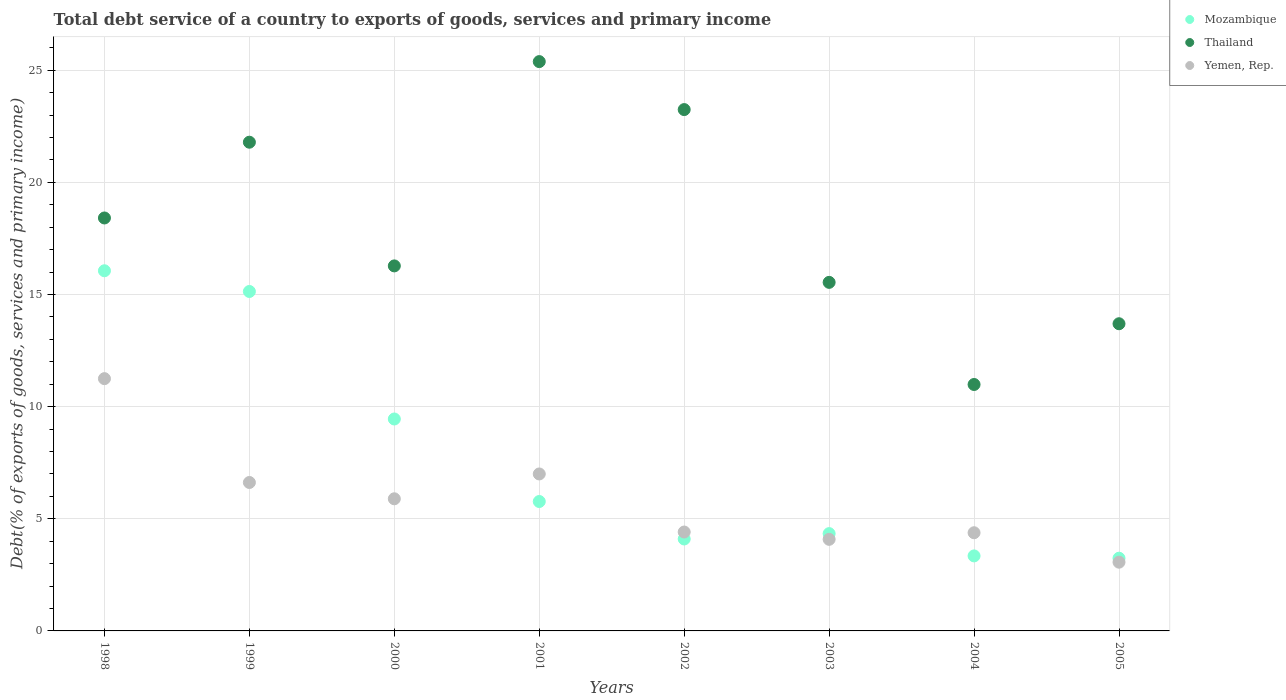How many different coloured dotlines are there?
Your answer should be compact. 3. Is the number of dotlines equal to the number of legend labels?
Ensure brevity in your answer.  Yes. What is the total debt service in Mozambique in 2001?
Offer a very short reply. 5.77. Across all years, what is the maximum total debt service in Mozambique?
Offer a very short reply. 16.06. Across all years, what is the minimum total debt service in Yemen, Rep.?
Give a very brief answer. 3.06. In which year was the total debt service in Thailand minimum?
Give a very brief answer. 2004. What is the total total debt service in Yemen, Rep. in the graph?
Your answer should be very brief. 46.69. What is the difference between the total debt service in Yemen, Rep. in 2001 and that in 2002?
Your response must be concise. 2.59. What is the difference between the total debt service in Thailand in 2004 and the total debt service in Yemen, Rep. in 1999?
Give a very brief answer. 4.37. What is the average total debt service in Yemen, Rep. per year?
Your answer should be very brief. 5.84. In the year 1998, what is the difference between the total debt service in Thailand and total debt service in Yemen, Rep.?
Offer a terse response. 7.16. In how many years, is the total debt service in Mozambique greater than 13 %?
Offer a terse response. 2. What is the ratio of the total debt service in Mozambique in 1999 to that in 2004?
Your answer should be very brief. 4.52. Is the total debt service in Yemen, Rep. in 2002 less than that in 2005?
Give a very brief answer. No. What is the difference between the highest and the second highest total debt service in Yemen, Rep.?
Ensure brevity in your answer.  4.25. What is the difference between the highest and the lowest total debt service in Yemen, Rep.?
Make the answer very short. 8.18. Is the sum of the total debt service in Thailand in 1998 and 1999 greater than the maximum total debt service in Mozambique across all years?
Give a very brief answer. Yes. Does the total debt service in Yemen, Rep. monotonically increase over the years?
Your answer should be very brief. No. Is the total debt service in Thailand strictly greater than the total debt service in Yemen, Rep. over the years?
Give a very brief answer. Yes. Is the total debt service in Thailand strictly less than the total debt service in Yemen, Rep. over the years?
Ensure brevity in your answer.  No. How many years are there in the graph?
Offer a terse response. 8. Does the graph contain any zero values?
Make the answer very short. No. Does the graph contain grids?
Make the answer very short. Yes. How are the legend labels stacked?
Offer a very short reply. Vertical. What is the title of the graph?
Provide a succinct answer. Total debt service of a country to exports of goods, services and primary income. What is the label or title of the X-axis?
Ensure brevity in your answer.  Years. What is the label or title of the Y-axis?
Keep it short and to the point. Debt(% of exports of goods, services and primary income). What is the Debt(% of exports of goods, services and primary income) in Mozambique in 1998?
Your answer should be compact. 16.06. What is the Debt(% of exports of goods, services and primary income) of Thailand in 1998?
Keep it short and to the point. 18.41. What is the Debt(% of exports of goods, services and primary income) in Yemen, Rep. in 1998?
Offer a very short reply. 11.25. What is the Debt(% of exports of goods, services and primary income) in Mozambique in 1999?
Make the answer very short. 15.14. What is the Debt(% of exports of goods, services and primary income) of Thailand in 1999?
Provide a short and direct response. 21.79. What is the Debt(% of exports of goods, services and primary income) of Yemen, Rep. in 1999?
Your response must be concise. 6.62. What is the Debt(% of exports of goods, services and primary income) in Mozambique in 2000?
Make the answer very short. 9.45. What is the Debt(% of exports of goods, services and primary income) in Thailand in 2000?
Offer a terse response. 16.28. What is the Debt(% of exports of goods, services and primary income) in Yemen, Rep. in 2000?
Your response must be concise. 5.89. What is the Debt(% of exports of goods, services and primary income) of Mozambique in 2001?
Make the answer very short. 5.77. What is the Debt(% of exports of goods, services and primary income) of Thailand in 2001?
Provide a short and direct response. 25.38. What is the Debt(% of exports of goods, services and primary income) in Yemen, Rep. in 2001?
Provide a short and direct response. 7. What is the Debt(% of exports of goods, services and primary income) in Mozambique in 2002?
Provide a short and direct response. 4.1. What is the Debt(% of exports of goods, services and primary income) of Thailand in 2002?
Your answer should be compact. 23.25. What is the Debt(% of exports of goods, services and primary income) in Yemen, Rep. in 2002?
Your answer should be compact. 4.41. What is the Debt(% of exports of goods, services and primary income) of Mozambique in 2003?
Your response must be concise. 4.34. What is the Debt(% of exports of goods, services and primary income) in Thailand in 2003?
Give a very brief answer. 15.54. What is the Debt(% of exports of goods, services and primary income) in Yemen, Rep. in 2003?
Make the answer very short. 4.08. What is the Debt(% of exports of goods, services and primary income) in Mozambique in 2004?
Keep it short and to the point. 3.34. What is the Debt(% of exports of goods, services and primary income) of Thailand in 2004?
Ensure brevity in your answer.  10.99. What is the Debt(% of exports of goods, services and primary income) in Yemen, Rep. in 2004?
Your answer should be compact. 4.38. What is the Debt(% of exports of goods, services and primary income) in Mozambique in 2005?
Give a very brief answer. 3.24. What is the Debt(% of exports of goods, services and primary income) in Thailand in 2005?
Make the answer very short. 13.7. What is the Debt(% of exports of goods, services and primary income) in Yemen, Rep. in 2005?
Provide a succinct answer. 3.06. Across all years, what is the maximum Debt(% of exports of goods, services and primary income) of Mozambique?
Offer a very short reply. 16.06. Across all years, what is the maximum Debt(% of exports of goods, services and primary income) in Thailand?
Keep it short and to the point. 25.38. Across all years, what is the maximum Debt(% of exports of goods, services and primary income) in Yemen, Rep.?
Keep it short and to the point. 11.25. Across all years, what is the minimum Debt(% of exports of goods, services and primary income) in Mozambique?
Your response must be concise. 3.24. Across all years, what is the minimum Debt(% of exports of goods, services and primary income) of Thailand?
Make the answer very short. 10.99. Across all years, what is the minimum Debt(% of exports of goods, services and primary income) in Yemen, Rep.?
Keep it short and to the point. 3.06. What is the total Debt(% of exports of goods, services and primary income) of Mozambique in the graph?
Provide a short and direct response. 61.44. What is the total Debt(% of exports of goods, services and primary income) in Thailand in the graph?
Your answer should be very brief. 145.34. What is the total Debt(% of exports of goods, services and primary income) of Yemen, Rep. in the graph?
Offer a terse response. 46.69. What is the difference between the Debt(% of exports of goods, services and primary income) of Mozambique in 1998 and that in 1999?
Give a very brief answer. 0.92. What is the difference between the Debt(% of exports of goods, services and primary income) of Thailand in 1998 and that in 1999?
Your response must be concise. -3.38. What is the difference between the Debt(% of exports of goods, services and primary income) in Yemen, Rep. in 1998 and that in 1999?
Keep it short and to the point. 4.63. What is the difference between the Debt(% of exports of goods, services and primary income) of Mozambique in 1998 and that in 2000?
Provide a short and direct response. 6.61. What is the difference between the Debt(% of exports of goods, services and primary income) of Thailand in 1998 and that in 2000?
Your response must be concise. 2.14. What is the difference between the Debt(% of exports of goods, services and primary income) of Yemen, Rep. in 1998 and that in 2000?
Offer a very short reply. 5.36. What is the difference between the Debt(% of exports of goods, services and primary income) in Mozambique in 1998 and that in 2001?
Provide a succinct answer. 10.29. What is the difference between the Debt(% of exports of goods, services and primary income) of Thailand in 1998 and that in 2001?
Make the answer very short. -6.97. What is the difference between the Debt(% of exports of goods, services and primary income) in Yemen, Rep. in 1998 and that in 2001?
Keep it short and to the point. 4.25. What is the difference between the Debt(% of exports of goods, services and primary income) in Mozambique in 1998 and that in 2002?
Provide a succinct answer. 11.96. What is the difference between the Debt(% of exports of goods, services and primary income) of Thailand in 1998 and that in 2002?
Make the answer very short. -4.83. What is the difference between the Debt(% of exports of goods, services and primary income) of Yemen, Rep. in 1998 and that in 2002?
Provide a short and direct response. 6.84. What is the difference between the Debt(% of exports of goods, services and primary income) of Mozambique in 1998 and that in 2003?
Keep it short and to the point. 11.72. What is the difference between the Debt(% of exports of goods, services and primary income) in Thailand in 1998 and that in 2003?
Offer a very short reply. 2.87. What is the difference between the Debt(% of exports of goods, services and primary income) in Yemen, Rep. in 1998 and that in 2003?
Keep it short and to the point. 7.16. What is the difference between the Debt(% of exports of goods, services and primary income) of Mozambique in 1998 and that in 2004?
Offer a very short reply. 12.71. What is the difference between the Debt(% of exports of goods, services and primary income) in Thailand in 1998 and that in 2004?
Offer a terse response. 7.43. What is the difference between the Debt(% of exports of goods, services and primary income) of Yemen, Rep. in 1998 and that in 2004?
Your answer should be very brief. 6.87. What is the difference between the Debt(% of exports of goods, services and primary income) of Mozambique in 1998 and that in 2005?
Offer a terse response. 12.82. What is the difference between the Debt(% of exports of goods, services and primary income) in Thailand in 1998 and that in 2005?
Keep it short and to the point. 4.72. What is the difference between the Debt(% of exports of goods, services and primary income) in Yemen, Rep. in 1998 and that in 2005?
Offer a terse response. 8.18. What is the difference between the Debt(% of exports of goods, services and primary income) of Mozambique in 1999 and that in 2000?
Your answer should be compact. 5.69. What is the difference between the Debt(% of exports of goods, services and primary income) of Thailand in 1999 and that in 2000?
Keep it short and to the point. 5.52. What is the difference between the Debt(% of exports of goods, services and primary income) in Yemen, Rep. in 1999 and that in 2000?
Make the answer very short. 0.73. What is the difference between the Debt(% of exports of goods, services and primary income) of Mozambique in 1999 and that in 2001?
Your answer should be very brief. 9.36. What is the difference between the Debt(% of exports of goods, services and primary income) of Thailand in 1999 and that in 2001?
Give a very brief answer. -3.59. What is the difference between the Debt(% of exports of goods, services and primary income) of Yemen, Rep. in 1999 and that in 2001?
Your answer should be very brief. -0.38. What is the difference between the Debt(% of exports of goods, services and primary income) of Mozambique in 1999 and that in 2002?
Keep it short and to the point. 11.04. What is the difference between the Debt(% of exports of goods, services and primary income) of Thailand in 1999 and that in 2002?
Give a very brief answer. -1.45. What is the difference between the Debt(% of exports of goods, services and primary income) of Yemen, Rep. in 1999 and that in 2002?
Ensure brevity in your answer.  2.21. What is the difference between the Debt(% of exports of goods, services and primary income) of Mozambique in 1999 and that in 2003?
Ensure brevity in your answer.  10.8. What is the difference between the Debt(% of exports of goods, services and primary income) in Thailand in 1999 and that in 2003?
Keep it short and to the point. 6.25. What is the difference between the Debt(% of exports of goods, services and primary income) in Yemen, Rep. in 1999 and that in 2003?
Your response must be concise. 2.54. What is the difference between the Debt(% of exports of goods, services and primary income) in Mozambique in 1999 and that in 2004?
Your answer should be very brief. 11.79. What is the difference between the Debt(% of exports of goods, services and primary income) of Thailand in 1999 and that in 2004?
Offer a very short reply. 10.8. What is the difference between the Debt(% of exports of goods, services and primary income) of Yemen, Rep. in 1999 and that in 2004?
Give a very brief answer. 2.24. What is the difference between the Debt(% of exports of goods, services and primary income) in Mozambique in 1999 and that in 2005?
Give a very brief answer. 11.89. What is the difference between the Debt(% of exports of goods, services and primary income) of Thailand in 1999 and that in 2005?
Your answer should be compact. 8.09. What is the difference between the Debt(% of exports of goods, services and primary income) in Yemen, Rep. in 1999 and that in 2005?
Ensure brevity in your answer.  3.55. What is the difference between the Debt(% of exports of goods, services and primary income) of Mozambique in 2000 and that in 2001?
Ensure brevity in your answer.  3.68. What is the difference between the Debt(% of exports of goods, services and primary income) of Thailand in 2000 and that in 2001?
Make the answer very short. -9.11. What is the difference between the Debt(% of exports of goods, services and primary income) in Yemen, Rep. in 2000 and that in 2001?
Keep it short and to the point. -1.11. What is the difference between the Debt(% of exports of goods, services and primary income) of Mozambique in 2000 and that in 2002?
Keep it short and to the point. 5.35. What is the difference between the Debt(% of exports of goods, services and primary income) of Thailand in 2000 and that in 2002?
Your response must be concise. -6.97. What is the difference between the Debt(% of exports of goods, services and primary income) in Yemen, Rep. in 2000 and that in 2002?
Offer a very short reply. 1.48. What is the difference between the Debt(% of exports of goods, services and primary income) of Mozambique in 2000 and that in 2003?
Ensure brevity in your answer.  5.11. What is the difference between the Debt(% of exports of goods, services and primary income) in Thailand in 2000 and that in 2003?
Your response must be concise. 0.73. What is the difference between the Debt(% of exports of goods, services and primary income) in Yemen, Rep. in 2000 and that in 2003?
Provide a succinct answer. 1.81. What is the difference between the Debt(% of exports of goods, services and primary income) in Mozambique in 2000 and that in 2004?
Give a very brief answer. 6.1. What is the difference between the Debt(% of exports of goods, services and primary income) of Thailand in 2000 and that in 2004?
Your answer should be compact. 5.29. What is the difference between the Debt(% of exports of goods, services and primary income) of Yemen, Rep. in 2000 and that in 2004?
Keep it short and to the point. 1.51. What is the difference between the Debt(% of exports of goods, services and primary income) in Mozambique in 2000 and that in 2005?
Offer a terse response. 6.21. What is the difference between the Debt(% of exports of goods, services and primary income) in Thailand in 2000 and that in 2005?
Your response must be concise. 2.58. What is the difference between the Debt(% of exports of goods, services and primary income) of Yemen, Rep. in 2000 and that in 2005?
Give a very brief answer. 2.83. What is the difference between the Debt(% of exports of goods, services and primary income) in Mozambique in 2001 and that in 2002?
Your answer should be compact. 1.67. What is the difference between the Debt(% of exports of goods, services and primary income) in Thailand in 2001 and that in 2002?
Keep it short and to the point. 2.14. What is the difference between the Debt(% of exports of goods, services and primary income) of Yemen, Rep. in 2001 and that in 2002?
Your answer should be compact. 2.59. What is the difference between the Debt(% of exports of goods, services and primary income) of Mozambique in 2001 and that in 2003?
Your answer should be compact. 1.43. What is the difference between the Debt(% of exports of goods, services and primary income) of Thailand in 2001 and that in 2003?
Provide a short and direct response. 9.84. What is the difference between the Debt(% of exports of goods, services and primary income) of Yemen, Rep. in 2001 and that in 2003?
Provide a succinct answer. 2.92. What is the difference between the Debt(% of exports of goods, services and primary income) in Mozambique in 2001 and that in 2004?
Give a very brief answer. 2.43. What is the difference between the Debt(% of exports of goods, services and primary income) in Thailand in 2001 and that in 2004?
Offer a very short reply. 14.4. What is the difference between the Debt(% of exports of goods, services and primary income) of Yemen, Rep. in 2001 and that in 2004?
Keep it short and to the point. 2.62. What is the difference between the Debt(% of exports of goods, services and primary income) in Mozambique in 2001 and that in 2005?
Give a very brief answer. 2.53. What is the difference between the Debt(% of exports of goods, services and primary income) of Thailand in 2001 and that in 2005?
Provide a succinct answer. 11.69. What is the difference between the Debt(% of exports of goods, services and primary income) in Yemen, Rep. in 2001 and that in 2005?
Ensure brevity in your answer.  3.93. What is the difference between the Debt(% of exports of goods, services and primary income) in Mozambique in 2002 and that in 2003?
Keep it short and to the point. -0.24. What is the difference between the Debt(% of exports of goods, services and primary income) of Thailand in 2002 and that in 2003?
Provide a succinct answer. 7.7. What is the difference between the Debt(% of exports of goods, services and primary income) of Yemen, Rep. in 2002 and that in 2003?
Make the answer very short. 0.33. What is the difference between the Debt(% of exports of goods, services and primary income) in Mozambique in 2002 and that in 2004?
Your response must be concise. 0.75. What is the difference between the Debt(% of exports of goods, services and primary income) of Thailand in 2002 and that in 2004?
Your response must be concise. 12.26. What is the difference between the Debt(% of exports of goods, services and primary income) in Yemen, Rep. in 2002 and that in 2004?
Provide a short and direct response. 0.03. What is the difference between the Debt(% of exports of goods, services and primary income) of Mozambique in 2002 and that in 2005?
Provide a short and direct response. 0.86. What is the difference between the Debt(% of exports of goods, services and primary income) of Thailand in 2002 and that in 2005?
Your answer should be very brief. 9.55. What is the difference between the Debt(% of exports of goods, services and primary income) in Yemen, Rep. in 2002 and that in 2005?
Your answer should be very brief. 1.34. What is the difference between the Debt(% of exports of goods, services and primary income) of Mozambique in 2003 and that in 2004?
Offer a very short reply. 0.99. What is the difference between the Debt(% of exports of goods, services and primary income) of Thailand in 2003 and that in 2004?
Your answer should be very brief. 4.55. What is the difference between the Debt(% of exports of goods, services and primary income) of Yemen, Rep. in 2003 and that in 2004?
Make the answer very short. -0.29. What is the difference between the Debt(% of exports of goods, services and primary income) in Mozambique in 2003 and that in 2005?
Keep it short and to the point. 1.1. What is the difference between the Debt(% of exports of goods, services and primary income) of Thailand in 2003 and that in 2005?
Your answer should be compact. 1.85. What is the difference between the Debt(% of exports of goods, services and primary income) of Yemen, Rep. in 2003 and that in 2005?
Offer a terse response. 1.02. What is the difference between the Debt(% of exports of goods, services and primary income) in Mozambique in 2004 and that in 2005?
Give a very brief answer. 0.1. What is the difference between the Debt(% of exports of goods, services and primary income) of Thailand in 2004 and that in 2005?
Provide a short and direct response. -2.71. What is the difference between the Debt(% of exports of goods, services and primary income) in Yemen, Rep. in 2004 and that in 2005?
Keep it short and to the point. 1.31. What is the difference between the Debt(% of exports of goods, services and primary income) of Mozambique in 1998 and the Debt(% of exports of goods, services and primary income) of Thailand in 1999?
Your response must be concise. -5.73. What is the difference between the Debt(% of exports of goods, services and primary income) in Mozambique in 1998 and the Debt(% of exports of goods, services and primary income) in Yemen, Rep. in 1999?
Your response must be concise. 9.44. What is the difference between the Debt(% of exports of goods, services and primary income) in Thailand in 1998 and the Debt(% of exports of goods, services and primary income) in Yemen, Rep. in 1999?
Offer a terse response. 11.79. What is the difference between the Debt(% of exports of goods, services and primary income) of Mozambique in 1998 and the Debt(% of exports of goods, services and primary income) of Thailand in 2000?
Provide a short and direct response. -0.22. What is the difference between the Debt(% of exports of goods, services and primary income) in Mozambique in 1998 and the Debt(% of exports of goods, services and primary income) in Yemen, Rep. in 2000?
Provide a succinct answer. 10.17. What is the difference between the Debt(% of exports of goods, services and primary income) in Thailand in 1998 and the Debt(% of exports of goods, services and primary income) in Yemen, Rep. in 2000?
Your answer should be compact. 12.52. What is the difference between the Debt(% of exports of goods, services and primary income) of Mozambique in 1998 and the Debt(% of exports of goods, services and primary income) of Thailand in 2001?
Keep it short and to the point. -9.33. What is the difference between the Debt(% of exports of goods, services and primary income) in Mozambique in 1998 and the Debt(% of exports of goods, services and primary income) in Yemen, Rep. in 2001?
Give a very brief answer. 9.06. What is the difference between the Debt(% of exports of goods, services and primary income) of Thailand in 1998 and the Debt(% of exports of goods, services and primary income) of Yemen, Rep. in 2001?
Offer a terse response. 11.41. What is the difference between the Debt(% of exports of goods, services and primary income) of Mozambique in 1998 and the Debt(% of exports of goods, services and primary income) of Thailand in 2002?
Make the answer very short. -7.19. What is the difference between the Debt(% of exports of goods, services and primary income) in Mozambique in 1998 and the Debt(% of exports of goods, services and primary income) in Yemen, Rep. in 2002?
Offer a terse response. 11.65. What is the difference between the Debt(% of exports of goods, services and primary income) of Thailand in 1998 and the Debt(% of exports of goods, services and primary income) of Yemen, Rep. in 2002?
Make the answer very short. 14. What is the difference between the Debt(% of exports of goods, services and primary income) of Mozambique in 1998 and the Debt(% of exports of goods, services and primary income) of Thailand in 2003?
Your answer should be compact. 0.52. What is the difference between the Debt(% of exports of goods, services and primary income) of Mozambique in 1998 and the Debt(% of exports of goods, services and primary income) of Yemen, Rep. in 2003?
Keep it short and to the point. 11.98. What is the difference between the Debt(% of exports of goods, services and primary income) of Thailand in 1998 and the Debt(% of exports of goods, services and primary income) of Yemen, Rep. in 2003?
Offer a very short reply. 14.33. What is the difference between the Debt(% of exports of goods, services and primary income) in Mozambique in 1998 and the Debt(% of exports of goods, services and primary income) in Thailand in 2004?
Your response must be concise. 5.07. What is the difference between the Debt(% of exports of goods, services and primary income) of Mozambique in 1998 and the Debt(% of exports of goods, services and primary income) of Yemen, Rep. in 2004?
Ensure brevity in your answer.  11.68. What is the difference between the Debt(% of exports of goods, services and primary income) in Thailand in 1998 and the Debt(% of exports of goods, services and primary income) in Yemen, Rep. in 2004?
Provide a succinct answer. 14.04. What is the difference between the Debt(% of exports of goods, services and primary income) of Mozambique in 1998 and the Debt(% of exports of goods, services and primary income) of Thailand in 2005?
Provide a succinct answer. 2.36. What is the difference between the Debt(% of exports of goods, services and primary income) of Mozambique in 1998 and the Debt(% of exports of goods, services and primary income) of Yemen, Rep. in 2005?
Make the answer very short. 12.99. What is the difference between the Debt(% of exports of goods, services and primary income) of Thailand in 1998 and the Debt(% of exports of goods, services and primary income) of Yemen, Rep. in 2005?
Ensure brevity in your answer.  15.35. What is the difference between the Debt(% of exports of goods, services and primary income) of Mozambique in 1999 and the Debt(% of exports of goods, services and primary income) of Thailand in 2000?
Give a very brief answer. -1.14. What is the difference between the Debt(% of exports of goods, services and primary income) in Mozambique in 1999 and the Debt(% of exports of goods, services and primary income) in Yemen, Rep. in 2000?
Offer a terse response. 9.24. What is the difference between the Debt(% of exports of goods, services and primary income) in Thailand in 1999 and the Debt(% of exports of goods, services and primary income) in Yemen, Rep. in 2000?
Your response must be concise. 15.9. What is the difference between the Debt(% of exports of goods, services and primary income) in Mozambique in 1999 and the Debt(% of exports of goods, services and primary income) in Thailand in 2001?
Provide a succinct answer. -10.25. What is the difference between the Debt(% of exports of goods, services and primary income) of Mozambique in 1999 and the Debt(% of exports of goods, services and primary income) of Yemen, Rep. in 2001?
Your response must be concise. 8.14. What is the difference between the Debt(% of exports of goods, services and primary income) of Thailand in 1999 and the Debt(% of exports of goods, services and primary income) of Yemen, Rep. in 2001?
Ensure brevity in your answer.  14.79. What is the difference between the Debt(% of exports of goods, services and primary income) of Mozambique in 1999 and the Debt(% of exports of goods, services and primary income) of Thailand in 2002?
Offer a very short reply. -8.11. What is the difference between the Debt(% of exports of goods, services and primary income) in Mozambique in 1999 and the Debt(% of exports of goods, services and primary income) in Yemen, Rep. in 2002?
Ensure brevity in your answer.  10.73. What is the difference between the Debt(% of exports of goods, services and primary income) of Thailand in 1999 and the Debt(% of exports of goods, services and primary income) of Yemen, Rep. in 2002?
Provide a succinct answer. 17.38. What is the difference between the Debt(% of exports of goods, services and primary income) in Mozambique in 1999 and the Debt(% of exports of goods, services and primary income) in Thailand in 2003?
Offer a terse response. -0.41. What is the difference between the Debt(% of exports of goods, services and primary income) in Mozambique in 1999 and the Debt(% of exports of goods, services and primary income) in Yemen, Rep. in 2003?
Make the answer very short. 11.05. What is the difference between the Debt(% of exports of goods, services and primary income) of Thailand in 1999 and the Debt(% of exports of goods, services and primary income) of Yemen, Rep. in 2003?
Make the answer very short. 17.71. What is the difference between the Debt(% of exports of goods, services and primary income) of Mozambique in 1999 and the Debt(% of exports of goods, services and primary income) of Thailand in 2004?
Provide a short and direct response. 4.15. What is the difference between the Debt(% of exports of goods, services and primary income) in Mozambique in 1999 and the Debt(% of exports of goods, services and primary income) in Yemen, Rep. in 2004?
Make the answer very short. 10.76. What is the difference between the Debt(% of exports of goods, services and primary income) in Thailand in 1999 and the Debt(% of exports of goods, services and primary income) in Yemen, Rep. in 2004?
Your response must be concise. 17.41. What is the difference between the Debt(% of exports of goods, services and primary income) of Mozambique in 1999 and the Debt(% of exports of goods, services and primary income) of Thailand in 2005?
Offer a very short reply. 1.44. What is the difference between the Debt(% of exports of goods, services and primary income) in Mozambique in 1999 and the Debt(% of exports of goods, services and primary income) in Yemen, Rep. in 2005?
Make the answer very short. 12.07. What is the difference between the Debt(% of exports of goods, services and primary income) of Thailand in 1999 and the Debt(% of exports of goods, services and primary income) of Yemen, Rep. in 2005?
Keep it short and to the point. 18.73. What is the difference between the Debt(% of exports of goods, services and primary income) in Mozambique in 2000 and the Debt(% of exports of goods, services and primary income) in Thailand in 2001?
Your answer should be compact. -15.94. What is the difference between the Debt(% of exports of goods, services and primary income) of Mozambique in 2000 and the Debt(% of exports of goods, services and primary income) of Yemen, Rep. in 2001?
Your answer should be compact. 2.45. What is the difference between the Debt(% of exports of goods, services and primary income) in Thailand in 2000 and the Debt(% of exports of goods, services and primary income) in Yemen, Rep. in 2001?
Offer a very short reply. 9.28. What is the difference between the Debt(% of exports of goods, services and primary income) in Mozambique in 2000 and the Debt(% of exports of goods, services and primary income) in Thailand in 2002?
Your answer should be compact. -13.8. What is the difference between the Debt(% of exports of goods, services and primary income) in Mozambique in 2000 and the Debt(% of exports of goods, services and primary income) in Yemen, Rep. in 2002?
Give a very brief answer. 5.04. What is the difference between the Debt(% of exports of goods, services and primary income) of Thailand in 2000 and the Debt(% of exports of goods, services and primary income) of Yemen, Rep. in 2002?
Your response must be concise. 11.87. What is the difference between the Debt(% of exports of goods, services and primary income) of Mozambique in 2000 and the Debt(% of exports of goods, services and primary income) of Thailand in 2003?
Give a very brief answer. -6.09. What is the difference between the Debt(% of exports of goods, services and primary income) in Mozambique in 2000 and the Debt(% of exports of goods, services and primary income) in Yemen, Rep. in 2003?
Keep it short and to the point. 5.37. What is the difference between the Debt(% of exports of goods, services and primary income) in Thailand in 2000 and the Debt(% of exports of goods, services and primary income) in Yemen, Rep. in 2003?
Keep it short and to the point. 12.19. What is the difference between the Debt(% of exports of goods, services and primary income) of Mozambique in 2000 and the Debt(% of exports of goods, services and primary income) of Thailand in 2004?
Offer a terse response. -1.54. What is the difference between the Debt(% of exports of goods, services and primary income) of Mozambique in 2000 and the Debt(% of exports of goods, services and primary income) of Yemen, Rep. in 2004?
Keep it short and to the point. 5.07. What is the difference between the Debt(% of exports of goods, services and primary income) of Thailand in 2000 and the Debt(% of exports of goods, services and primary income) of Yemen, Rep. in 2004?
Keep it short and to the point. 11.9. What is the difference between the Debt(% of exports of goods, services and primary income) in Mozambique in 2000 and the Debt(% of exports of goods, services and primary income) in Thailand in 2005?
Provide a short and direct response. -4.25. What is the difference between the Debt(% of exports of goods, services and primary income) of Mozambique in 2000 and the Debt(% of exports of goods, services and primary income) of Yemen, Rep. in 2005?
Your answer should be very brief. 6.38. What is the difference between the Debt(% of exports of goods, services and primary income) of Thailand in 2000 and the Debt(% of exports of goods, services and primary income) of Yemen, Rep. in 2005?
Provide a short and direct response. 13.21. What is the difference between the Debt(% of exports of goods, services and primary income) of Mozambique in 2001 and the Debt(% of exports of goods, services and primary income) of Thailand in 2002?
Your answer should be very brief. -17.48. What is the difference between the Debt(% of exports of goods, services and primary income) in Mozambique in 2001 and the Debt(% of exports of goods, services and primary income) in Yemen, Rep. in 2002?
Keep it short and to the point. 1.36. What is the difference between the Debt(% of exports of goods, services and primary income) in Thailand in 2001 and the Debt(% of exports of goods, services and primary income) in Yemen, Rep. in 2002?
Ensure brevity in your answer.  20.98. What is the difference between the Debt(% of exports of goods, services and primary income) in Mozambique in 2001 and the Debt(% of exports of goods, services and primary income) in Thailand in 2003?
Offer a terse response. -9.77. What is the difference between the Debt(% of exports of goods, services and primary income) of Mozambique in 2001 and the Debt(% of exports of goods, services and primary income) of Yemen, Rep. in 2003?
Provide a succinct answer. 1.69. What is the difference between the Debt(% of exports of goods, services and primary income) of Thailand in 2001 and the Debt(% of exports of goods, services and primary income) of Yemen, Rep. in 2003?
Make the answer very short. 21.3. What is the difference between the Debt(% of exports of goods, services and primary income) in Mozambique in 2001 and the Debt(% of exports of goods, services and primary income) in Thailand in 2004?
Keep it short and to the point. -5.22. What is the difference between the Debt(% of exports of goods, services and primary income) of Mozambique in 2001 and the Debt(% of exports of goods, services and primary income) of Yemen, Rep. in 2004?
Your answer should be very brief. 1.39. What is the difference between the Debt(% of exports of goods, services and primary income) in Thailand in 2001 and the Debt(% of exports of goods, services and primary income) in Yemen, Rep. in 2004?
Offer a terse response. 21.01. What is the difference between the Debt(% of exports of goods, services and primary income) of Mozambique in 2001 and the Debt(% of exports of goods, services and primary income) of Thailand in 2005?
Your answer should be compact. -7.93. What is the difference between the Debt(% of exports of goods, services and primary income) in Mozambique in 2001 and the Debt(% of exports of goods, services and primary income) in Yemen, Rep. in 2005?
Give a very brief answer. 2.71. What is the difference between the Debt(% of exports of goods, services and primary income) in Thailand in 2001 and the Debt(% of exports of goods, services and primary income) in Yemen, Rep. in 2005?
Make the answer very short. 22.32. What is the difference between the Debt(% of exports of goods, services and primary income) of Mozambique in 2002 and the Debt(% of exports of goods, services and primary income) of Thailand in 2003?
Your answer should be compact. -11.44. What is the difference between the Debt(% of exports of goods, services and primary income) in Mozambique in 2002 and the Debt(% of exports of goods, services and primary income) in Yemen, Rep. in 2003?
Offer a very short reply. 0.02. What is the difference between the Debt(% of exports of goods, services and primary income) in Thailand in 2002 and the Debt(% of exports of goods, services and primary income) in Yemen, Rep. in 2003?
Provide a succinct answer. 19.16. What is the difference between the Debt(% of exports of goods, services and primary income) in Mozambique in 2002 and the Debt(% of exports of goods, services and primary income) in Thailand in 2004?
Your response must be concise. -6.89. What is the difference between the Debt(% of exports of goods, services and primary income) in Mozambique in 2002 and the Debt(% of exports of goods, services and primary income) in Yemen, Rep. in 2004?
Offer a very short reply. -0.28. What is the difference between the Debt(% of exports of goods, services and primary income) of Thailand in 2002 and the Debt(% of exports of goods, services and primary income) of Yemen, Rep. in 2004?
Your answer should be very brief. 18.87. What is the difference between the Debt(% of exports of goods, services and primary income) of Mozambique in 2002 and the Debt(% of exports of goods, services and primary income) of Thailand in 2005?
Provide a short and direct response. -9.6. What is the difference between the Debt(% of exports of goods, services and primary income) in Mozambique in 2002 and the Debt(% of exports of goods, services and primary income) in Yemen, Rep. in 2005?
Make the answer very short. 1.03. What is the difference between the Debt(% of exports of goods, services and primary income) of Thailand in 2002 and the Debt(% of exports of goods, services and primary income) of Yemen, Rep. in 2005?
Make the answer very short. 20.18. What is the difference between the Debt(% of exports of goods, services and primary income) in Mozambique in 2003 and the Debt(% of exports of goods, services and primary income) in Thailand in 2004?
Keep it short and to the point. -6.65. What is the difference between the Debt(% of exports of goods, services and primary income) of Mozambique in 2003 and the Debt(% of exports of goods, services and primary income) of Yemen, Rep. in 2004?
Provide a short and direct response. -0.04. What is the difference between the Debt(% of exports of goods, services and primary income) of Thailand in 2003 and the Debt(% of exports of goods, services and primary income) of Yemen, Rep. in 2004?
Offer a terse response. 11.16. What is the difference between the Debt(% of exports of goods, services and primary income) of Mozambique in 2003 and the Debt(% of exports of goods, services and primary income) of Thailand in 2005?
Provide a short and direct response. -9.36. What is the difference between the Debt(% of exports of goods, services and primary income) of Mozambique in 2003 and the Debt(% of exports of goods, services and primary income) of Yemen, Rep. in 2005?
Provide a succinct answer. 1.27. What is the difference between the Debt(% of exports of goods, services and primary income) in Thailand in 2003 and the Debt(% of exports of goods, services and primary income) in Yemen, Rep. in 2005?
Provide a succinct answer. 12.48. What is the difference between the Debt(% of exports of goods, services and primary income) of Mozambique in 2004 and the Debt(% of exports of goods, services and primary income) of Thailand in 2005?
Give a very brief answer. -10.35. What is the difference between the Debt(% of exports of goods, services and primary income) of Mozambique in 2004 and the Debt(% of exports of goods, services and primary income) of Yemen, Rep. in 2005?
Provide a succinct answer. 0.28. What is the difference between the Debt(% of exports of goods, services and primary income) in Thailand in 2004 and the Debt(% of exports of goods, services and primary income) in Yemen, Rep. in 2005?
Your response must be concise. 7.92. What is the average Debt(% of exports of goods, services and primary income) in Mozambique per year?
Your answer should be very brief. 7.68. What is the average Debt(% of exports of goods, services and primary income) of Thailand per year?
Your answer should be very brief. 18.17. What is the average Debt(% of exports of goods, services and primary income) of Yemen, Rep. per year?
Ensure brevity in your answer.  5.84. In the year 1998, what is the difference between the Debt(% of exports of goods, services and primary income) in Mozambique and Debt(% of exports of goods, services and primary income) in Thailand?
Your response must be concise. -2.35. In the year 1998, what is the difference between the Debt(% of exports of goods, services and primary income) in Mozambique and Debt(% of exports of goods, services and primary income) in Yemen, Rep.?
Keep it short and to the point. 4.81. In the year 1998, what is the difference between the Debt(% of exports of goods, services and primary income) of Thailand and Debt(% of exports of goods, services and primary income) of Yemen, Rep.?
Ensure brevity in your answer.  7.16. In the year 1999, what is the difference between the Debt(% of exports of goods, services and primary income) of Mozambique and Debt(% of exports of goods, services and primary income) of Thailand?
Provide a short and direct response. -6.66. In the year 1999, what is the difference between the Debt(% of exports of goods, services and primary income) of Mozambique and Debt(% of exports of goods, services and primary income) of Yemen, Rep.?
Your answer should be very brief. 8.52. In the year 1999, what is the difference between the Debt(% of exports of goods, services and primary income) of Thailand and Debt(% of exports of goods, services and primary income) of Yemen, Rep.?
Make the answer very short. 15.17. In the year 2000, what is the difference between the Debt(% of exports of goods, services and primary income) in Mozambique and Debt(% of exports of goods, services and primary income) in Thailand?
Offer a terse response. -6.83. In the year 2000, what is the difference between the Debt(% of exports of goods, services and primary income) in Mozambique and Debt(% of exports of goods, services and primary income) in Yemen, Rep.?
Make the answer very short. 3.56. In the year 2000, what is the difference between the Debt(% of exports of goods, services and primary income) in Thailand and Debt(% of exports of goods, services and primary income) in Yemen, Rep.?
Provide a succinct answer. 10.38. In the year 2001, what is the difference between the Debt(% of exports of goods, services and primary income) in Mozambique and Debt(% of exports of goods, services and primary income) in Thailand?
Your answer should be compact. -19.61. In the year 2001, what is the difference between the Debt(% of exports of goods, services and primary income) of Mozambique and Debt(% of exports of goods, services and primary income) of Yemen, Rep.?
Make the answer very short. -1.23. In the year 2001, what is the difference between the Debt(% of exports of goods, services and primary income) of Thailand and Debt(% of exports of goods, services and primary income) of Yemen, Rep.?
Give a very brief answer. 18.39. In the year 2002, what is the difference between the Debt(% of exports of goods, services and primary income) of Mozambique and Debt(% of exports of goods, services and primary income) of Thailand?
Provide a succinct answer. -19.15. In the year 2002, what is the difference between the Debt(% of exports of goods, services and primary income) of Mozambique and Debt(% of exports of goods, services and primary income) of Yemen, Rep.?
Your answer should be compact. -0.31. In the year 2002, what is the difference between the Debt(% of exports of goods, services and primary income) of Thailand and Debt(% of exports of goods, services and primary income) of Yemen, Rep.?
Your response must be concise. 18.84. In the year 2003, what is the difference between the Debt(% of exports of goods, services and primary income) in Mozambique and Debt(% of exports of goods, services and primary income) in Thailand?
Make the answer very short. -11.2. In the year 2003, what is the difference between the Debt(% of exports of goods, services and primary income) of Mozambique and Debt(% of exports of goods, services and primary income) of Yemen, Rep.?
Your answer should be very brief. 0.26. In the year 2003, what is the difference between the Debt(% of exports of goods, services and primary income) in Thailand and Debt(% of exports of goods, services and primary income) in Yemen, Rep.?
Provide a short and direct response. 11.46. In the year 2004, what is the difference between the Debt(% of exports of goods, services and primary income) of Mozambique and Debt(% of exports of goods, services and primary income) of Thailand?
Offer a terse response. -7.64. In the year 2004, what is the difference between the Debt(% of exports of goods, services and primary income) in Mozambique and Debt(% of exports of goods, services and primary income) in Yemen, Rep.?
Your response must be concise. -1.03. In the year 2004, what is the difference between the Debt(% of exports of goods, services and primary income) of Thailand and Debt(% of exports of goods, services and primary income) of Yemen, Rep.?
Your response must be concise. 6.61. In the year 2005, what is the difference between the Debt(% of exports of goods, services and primary income) of Mozambique and Debt(% of exports of goods, services and primary income) of Thailand?
Your answer should be compact. -10.45. In the year 2005, what is the difference between the Debt(% of exports of goods, services and primary income) of Mozambique and Debt(% of exports of goods, services and primary income) of Yemen, Rep.?
Your response must be concise. 0.18. In the year 2005, what is the difference between the Debt(% of exports of goods, services and primary income) in Thailand and Debt(% of exports of goods, services and primary income) in Yemen, Rep.?
Make the answer very short. 10.63. What is the ratio of the Debt(% of exports of goods, services and primary income) in Mozambique in 1998 to that in 1999?
Ensure brevity in your answer.  1.06. What is the ratio of the Debt(% of exports of goods, services and primary income) in Thailand in 1998 to that in 1999?
Your answer should be compact. 0.84. What is the ratio of the Debt(% of exports of goods, services and primary income) of Yemen, Rep. in 1998 to that in 1999?
Give a very brief answer. 1.7. What is the ratio of the Debt(% of exports of goods, services and primary income) in Mozambique in 1998 to that in 2000?
Your answer should be very brief. 1.7. What is the ratio of the Debt(% of exports of goods, services and primary income) of Thailand in 1998 to that in 2000?
Give a very brief answer. 1.13. What is the ratio of the Debt(% of exports of goods, services and primary income) of Yemen, Rep. in 1998 to that in 2000?
Provide a short and direct response. 1.91. What is the ratio of the Debt(% of exports of goods, services and primary income) of Mozambique in 1998 to that in 2001?
Provide a succinct answer. 2.78. What is the ratio of the Debt(% of exports of goods, services and primary income) of Thailand in 1998 to that in 2001?
Give a very brief answer. 0.73. What is the ratio of the Debt(% of exports of goods, services and primary income) of Yemen, Rep. in 1998 to that in 2001?
Provide a short and direct response. 1.61. What is the ratio of the Debt(% of exports of goods, services and primary income) of Mozambique in 1998 to that in 2002?
Provide a short and direct response. 3.92. What is the ratio of the Debt(% of exports of goods, services and primary income) of Thailand in 1998 to that in 2002?
Provide a succinct answer. 0.79. What is the ratio of the Debt(% of exports of goods, services and primary income) in Yemen, Rep. in 1998 to that in 2002?
Give a very brief answer. 2.55. What is the ratio of the Debt(% of exports of goods, services and primary income) of Mozambique in 1998 to that in 2003?
Your answer should be very brief. 3.7. What is the ratio of the Debt(% of exports of goods, services and primary income) of Thailand in 1998 to that in 2003?
Provide a short and direct response. 1.18. What is the ratio of the Debt(% of exports of goods, services and primary income) in Yemen, Rep. in 1998 to that in 2003?
Give a very brief answer. 2.75. What is the ratio of the Debt(% of exports of goods, services and primary income) in Mozambique in 1998 to that in 2004?
Your response must be concise. 4.8. What is the ratio of the Debt(% of exports of goods, services and primary income) of Thailand in 1998 to that in 2004?
Your response must be concise. 1.68. What is the ratio of the Debt(% of exports of goods, services and primary income) of Yemen, Rep. in 1998 to that in 2004?
Your answer should be compact. 2.57. What is the ratio of the Debt(% of exports of goods, services and primary income) in Mozambique in 1998 to that in 2005?
Provide a succinct answer. 4.95. What is the ratio of the Debt(% of exports of goods, services and primary income) of Thailand in 1998 to that in 2005?
Provide a short and direct response. 1.34. What is the ratio of the Debt(% of exports of goods, services and primary income) in Yemen, Rep. in 1998 to that in 2005?
Give a very brief answer. 3.67. What is the ratio of the Debt(% of exports of goods, services and primary income) in Mozambique in 1999 to that in 2000?
Offer a terse response. 1.6. What is the ratio of the Debt(% of exports of goods, services and primary income) of Thailand in 1999 to that in 2000?
Offer a very short reply. 1.34. What is the ratio of the Debt(% of exports of goods, services and primary income) in Yemen, Rep. in 1999 to that in 2000?
Provide a short and direct response. 1.12. What is the ratio of the Debt(% of exports of goods, services and primary income) in Mozambique in 1999 to that in 2001?
Provide a short and direct response. 2.62. What is the ratio of the Debt(% of exports of goods, services and primary income) of Thailand in 1999 to that in 2001?
Make the answer very short. 0.86. What is the ratio of the Debt(% of exports of goods, services and primary income) of Yemen, Rep. in 1999 to that in 2001?
Give a very brief answer. 0.95. What is the ratio of the Debt(% of exports of goods, services and primary income) in Mozambique in 1999 to that in 2002?
Your answer should be compact. 3.69. What is the ratio of the Debt(% of exports of goods, services and primary income) of Thailand in 1999 to that in 2002?
Offer a terse response. 0.94. What is the ratio of the Debt(% of exports of goods, services and primary income) in Yemen, Rep. in 1999 to that in 2002?
Provide a succinct answer. 1.5. What is the ratio of the Debt(% of exports of goods, services and primary income) of Mozambique in 1999 to that in 2003?
Offer a very short reply. 3.49. What is the ratio of the Debt(% of exports of goods, services and primary income) in Thailand in 1999 to that in 2003?
Keep it short and to the point. 1.4. What is the ratio of the Debt(% of exports of goods, services and primary income) in Yemen, Rep. in 1999 to that in 2003?
Offer a very short reply. 1.62. What is the ratio of the Debt(% of exports of goods, services and primary income) in Mozambique in 1999 to that in 2004?
Ensure brevity in your answer.  4.53. What is the ratio of the Debt(% of exports of goods, services and primary income) in Thailand in 1999 to that in 2004?
Your response must be concise. 1.98. What is the ratio of the Debt(% of exports of goods, services and primary income) of Yemen, Rep. in 1999 to that in 2004?
Offer a terse response. 1.51. What is the ratio of the Debt(% of exports of goods, services and primary income) of Mozambique in 1999 to that in 2005?
Ensure brevity in your answer.  4.67. What is the ratio of the Debt(% of exports of goods, services and primary income) of Thailand in 1999 to that in 2005?
Give a very brief answer. 1.59. What is the ratio of the Debt(% of exports of goods, services and primary income) of Yemen, Rep. in 1999 to that in 2005?
Your answer should be compact. 2.16. What is the ratio of the Debt(% of exports of goods, services and primary income) in Mozambique in 2000 to that in 2001?
Offer a very short reply. 1.64. What is the ratio of the Debt(% of exports of goods, services and primary income) in Thailand in 2000 to that in 2001?
Keep it short and to the point. 0.64. What is the ratio of the Debt(% of exports of goods, services and primary income) in Yemen, Rep. in 2000 to that in 2001?
Your response must be concise. 0.84. What is the ratio of the Debt(% of exports of goods, services and primary income) of Mozambique in 2000 to that in 2002?
Keep it short and to the point. 2.31. What is the ratio of the Debt(% of exports of goods, services and primary income) in Thailand in 2000 to that in 2002?
Keep it short and to the point. 0.7. What is the ratio of the Debt(% of exports of goods, services and primary income) of Yemen, Rep. in 2000 to that in 2002?
Offer a terse response. 1.34. What is the ratio of the Debt(% of exports of goods, services and primary income) of Mozambique in 2000 to that in 2003?
Your response must be concise. 2.18. What is the ratio of the Debt(% of exports of goods, services and primary income) in Thailand in 2000 to that in 2003?
Give a very brief answer. 1.05. What is the ratio of the Debt(% of exports of goods, services and primary income) in Yemen, Rep. in 2000 to that in 2003?
Provide a short and direct response. 1.44. What is the ratio of the Debt(% of exports of goods, services and primary income) of Mozambique in 2000 to that in 2004?
Offer a terse response. 2.83. What is the ratio of the Debt(% of exports of goods, services and primary income) of Thailand in 2000 to that in 2004?
Your response must be concise. 1.48. What is the ratio of the Debt(% of exports of goods, services and primary income) of Yemen, Rep. in 2000 to that in 2004?
Your answer should be very brief. 1.35. What is the ratio of the Debt(% of exports of goods, services and primary income) of Mozambique in 2000 to that in 2005?
Your response must be concise. 2.91. What is the ratio of the Debt(% of exports of goods, services and primary income) of Thailand in 2000 to that in 2005?
Provide a succinct answer. 1.19. What is the ratio of the Debt(% of exports of goods, services and primary income) in Yemen, Rep. in 2000 to that in 2005?
Offer a very short reply. 1.92. What is the ratio of the Debt(% of exports of goods, services and primary income) in Mozambique in 2001 to that in 2002?
Make the answer very short. 1.41. What is the ratio of the Debt(% of exports of goods, services and primary income) of Thailand in 2001 to that in 2002?
Ensure brevity in your answer.  1.09. What is the ratio of the Debt(% of exports of goods, services and primary income) of Yemen, Rep. in 2001 to that in 2002?
Ensure brevity in your answer.  1.59. What is the ratio of the Debt(% of exports of goods, services and primary income) of Mozambique in 2001 to that in 2003?
Keep it short and to the point. 1.33. What is the ratio of the Debt(% of exports of goods, services and primary income) in Thailand in 2001 to that in 2003?
Your answer should be compact. 1.63. What is the ratio of the Debt(% of exports of goods, services and primary income) in Yemen, Rep. in 2001 to that in 2003?
Your answer should be very brief. 1.71. What is the ratio of the Debt(% of exports of goods, services and primary income) in Mozambique in 2001 to that in 2004?
Your answer should be compact. 1.73. What is the ratio of the Debt(% of exports of goods, services and primary income) in Thailand in 2001 to that in 2004?
Your answer should be compact. 2.31. What is the ratio of the Debt(% of exports of goods, services and primary income) in Yemen, Rep. in 2001 to that in 2004?
Make the answer very short. 1.6. What is the ratio of the Debt(% of exports of goods, services and primary income) in Mozambique in 2001 to that in 2005?
Offer a terse response. 1.78. What is the ratio of the Debt(% of exports of goods, services and primary income) of Thailand in 2001 to that in 2005?
Provide a succinct answer. 1.85. What is the ratio of the Debt(% of exports of goods, services and primary income) in Yemen, Rep. in 2001 to that in 2005?
Your answer should be compact. 2.28. What is the ratio of the Debt(% of exports of goods, services and primary income) of Mozambique in 2002 to that in 2003?
Ensure brevity in your answer.  0.94. What is the ratio of the Debt(% of exports of goods, services and primary income) in Thailand in 2002 to that in 2003?
Give a very brief answer. 1.5. What is the ratio of the Debt(% of exports of goods, services and primary income) in Yemen, Rep. in 2002 to that in 2003?
Your answer should be compact. 1.08. What is the ratio of the Debt(% of exports of goods, services and primary income) in Mozambique in 2002 to that in 2004?
Ensure brevity in your answer.  1.23. What is the ratio of the Debt(% of exports of goods, services and primary income) of Thailand in 2002 to that in 2004?
Provide a succinct answer. 2.12. What is the ratio of the Debt(% of exports of goods, services and primary income) in Yemen, Rep. in 2002 to that in 2004?
Your response must be concise. 1.01. What is the ratio of the Debt(% of exports of goods, services and primary income) in Mozambique in 2002 to that in 2005?
Keep it short and to the point. 1.26. What is the ratio of the Debt(% of exports of goods, services and primary income) of Thailand in 2002 to that in 2005?
Offer a very short reply. 1.7. What is the ratio of the Debt(% of exports of goods, services and primary income) of Yemen, Rep. in 2002 to that in 2005?
Make the answer very short. 1.44. What is the ratio of the Debt(% of exports of goods, services and primary income) of Mozambique in 2003 to that in 2004?
Provide a short and direct response. 1.3. What is the ratio of the Debt(% of exports of goods, services and primary income) in Thailand in 2003 to that in 2004?
Your answer should be very brief. 1.41. What is the ratio of the Debt(% of exports of goods, services and primary income) in Yemen, Rep. in 2003 to that in 2004?
Ensure brevity in your answer.  0.93. What is the ratio of the Debt(% of exports of goods, services and primary income) in Mozambique in 2003 to that in 2005?
Your answer should be compact. 1.34. What is the ratio of the Debt(% of exports of goods, services and primary income) in Thailand in 2003 to that in 2005?
Ensure brevity in your answer.  1.13. What is the ratio of the Debt(% of exports of goods, services and primary income) in Yemen, Rep. in 2003 to that in 2005?
Offer a very short reply. 1.33. What is the ratio of the Debt(% of exports of goods, services and primary income) in Mozambique in 2004 to that in 2005?
Keep it short and to the point. 1.03. What is the ratio of the Debt(% of exports of goods, services and primary income) of Thailand in 2004 to that in 2005?
Offer a very short reply. 0.8. What is the ratio of the Debt(% of exports of goods, services and primary income) of Yemen, Rep. in 2004 to that in 2005?
Make the answer very short. 1.43. What is the difference between the highest and the second highest Debt(% of exports of goods, services and primary income) in Mozambique?
Your answer should be very brief. 0.92. What is the difference between the highest and the second highest Debt(% of exports of goods, services and primary income) in Thailand?
Your response must be concise. 2.14. What is the difference between the highest and the second highest Debt(% of exports of goods, services and primary income) in Yemen, Rep.?
Give a very brief answer. 4.25. What is the difference between the highest and the lowest Debt(% of exports of goods, services and primary income) of Mozambique?
Your response must be concise. 12.82. What is the difference between the highest and the lowest Debt(% of exports of goods, services and primary income) in Thailand?
Keep it short and to the point. 14.4. What is the difference between the highest and the lowest Debt(% of exports of goods, services and primary income) of Yemen, Rep.?
Your response must be concise. 8.18. 